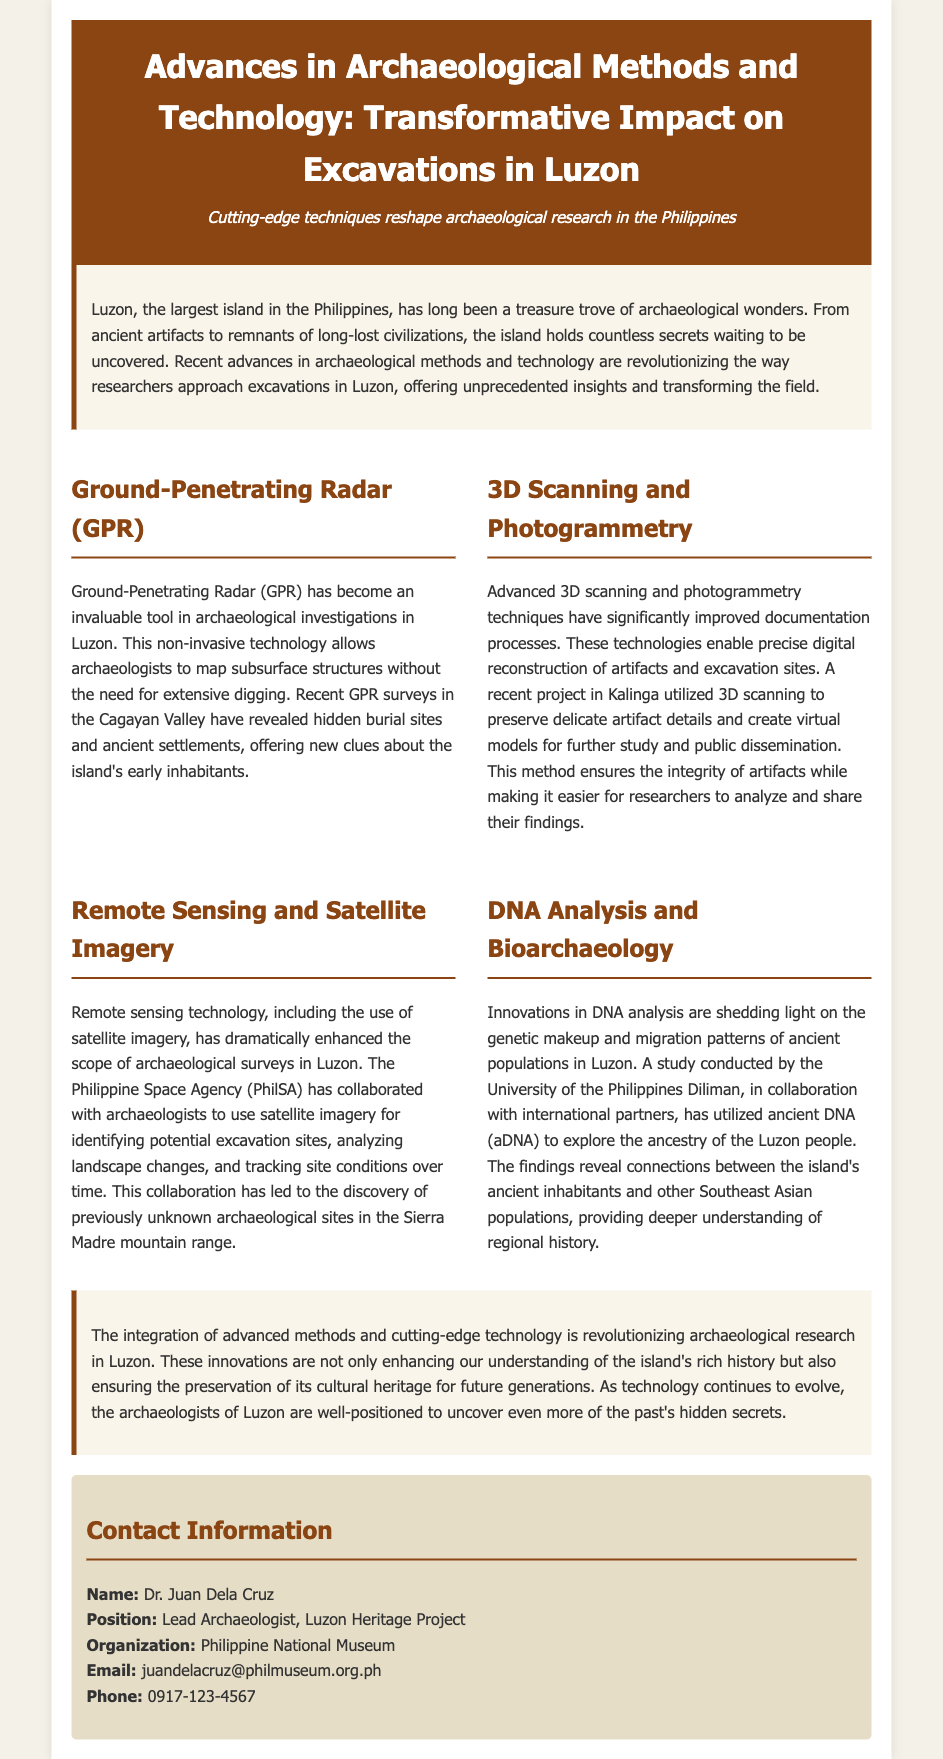What technology allows mapping subsurface structures? The document mentions Ground-Penetrating Radar (GPR) as an invaluable tool for mapping subsurface structures non-invasively.
Answer: Ground-Penetrating Radar (GPR) Which valley revealed hidden burial sites through GPR surveys? The GPR surveys conducted in the Cagayan Valley revealed hidden burial sites and ancient settlements.
Answer: Cagayan Valley What advanced technique was used in Kalinga for artifact preservation? Advanced 3D scanning was utilized in Kalinga to preserve delicate artifact details and create virtual models.
Answer: 3D scanning Which organization collaborated with archaeologists to use satellite imagery? The Philippine Space Agency (PhilSA) collaborated with archaeologists to use satellite imagery for archaeological surveys.
Answer: Philippine Space Agency What kind of analysis is helping to explore the ancestry of Luzon people? The document highlights innovations in DNA analysis as a key method for exploring the ancestry of the Luzon people.
Answer: DNA analysis How has technology impacted archaeological research in Luzon? The integration of advanced methods and technology is revolutionizing archaeological research and enhancing the understanding of history.
Answer: Revolutionizing Who is the lead archaeologist mentioned in the contact information? The name provided in the contact information for the lead archaeologist is Dr. Juan Dela Cruz.
Answer: Dr. Juan Dela Cruz What is the main focus of advances in archaeological methods according to the document? The main focus of the advances discussed is on transformative impacts on excavations in Luzon.
Answer: Transformative impacts What is the purpose of using 3D scanning in archaeology? The purpose of using 3D scanning is to ensure the integrity of artifacts while facilitating analysis and public dissemination.
Answer: Preserve artifact integrity How does the document describe the potential future of archaeological research in Luzon? It mentions that as technology evolves, archaeologists in Luzon are well-positioned to uncover more hidden secrets from the past.
Answer: Uncover more secrets 